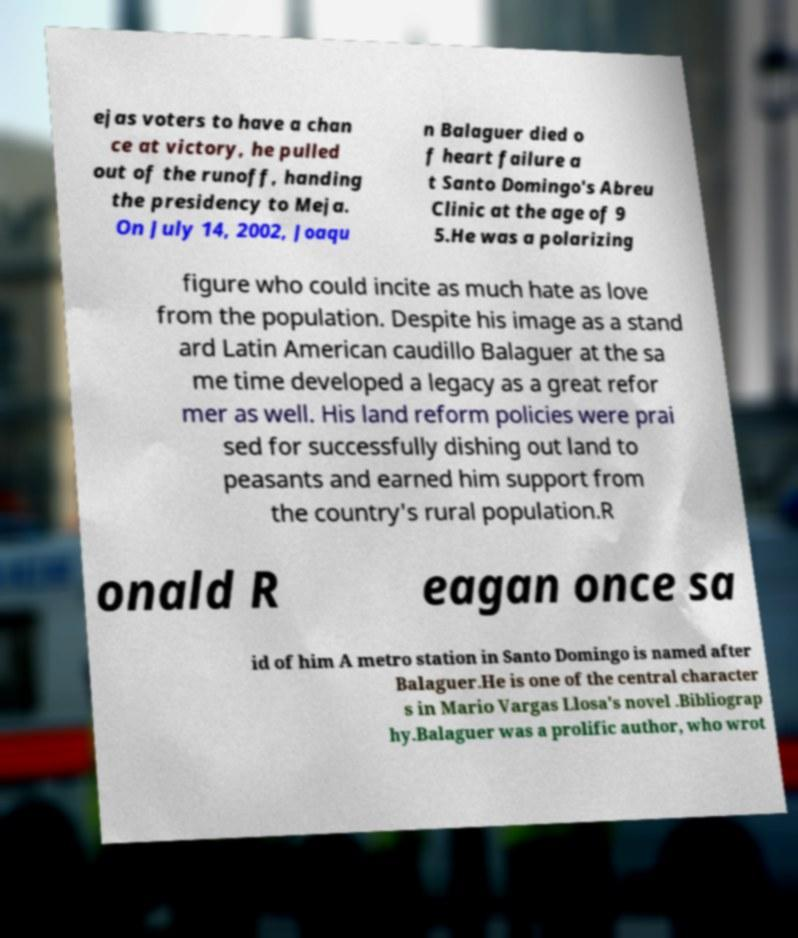Please read and relay the text visible in this image. What does it say? ejas voters to have a chan ce at victory, he pulled out of the runoff, handing the presidency to Meja. On July 14, 2002, Joaqu n Balaguer died o f heart failure a t Santo Domingo's Abreu Clinic at the age of 9 5.He was a polarizing figure who could incite as much hate as love from the population. Despite his image as a stand ard Latin American caudillo Balaguer at the sa me time developed a legacy as a great refor mer as well. His land reform policies were prai sed for successfully dishing out land to peasants and earned him support from the country's rural population.R onald R eagan once sa id of him A metro station in Santo Domingo is named after Balaguer.He is one of the central character s in Mario Vargas Llosa's novel .Bibliograp hy.Balaguer was a prolific author, who wrot 